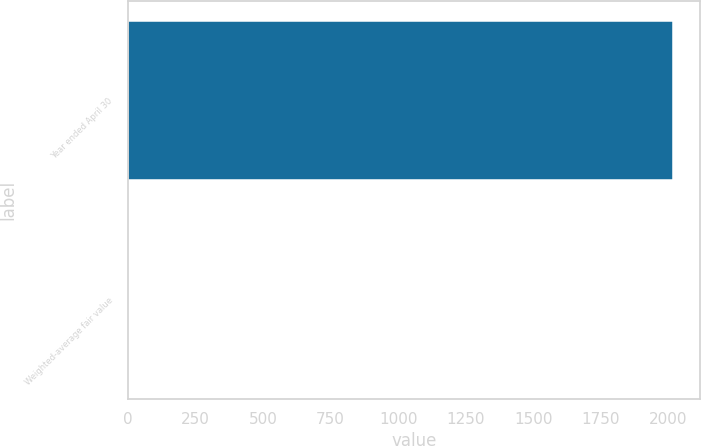<chart> <loc_0><loc_0><loc_500><loc_500><bar_chart><fcel>Year ended April 30<fcel>Weighted-average fair value<nl><fcel>2016<fcel>5.28<nl></chart> 